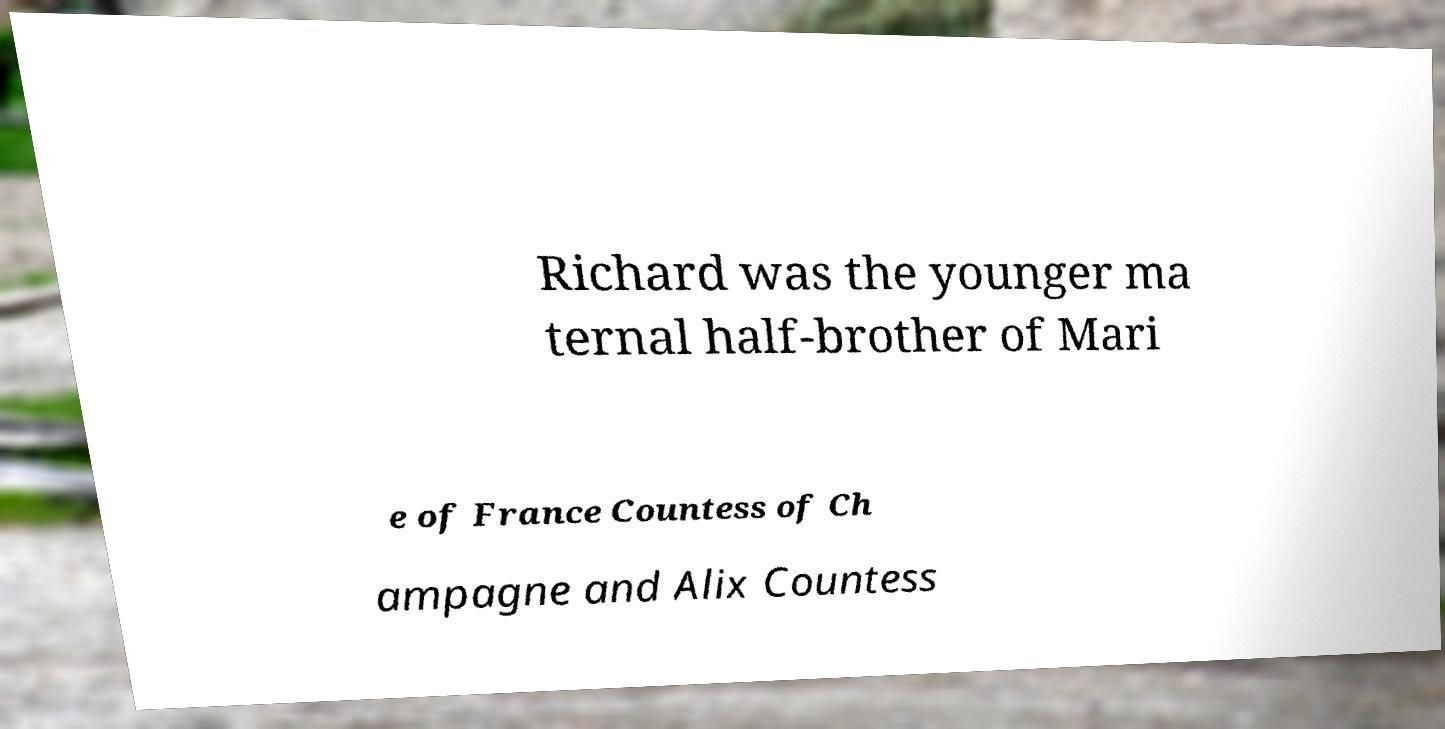Can you accurately transcribe the text from the provided image for me? Richard was the younger ma ternal half-brother of Mari e of France Countess of Ch ampagne and Alix Countess 